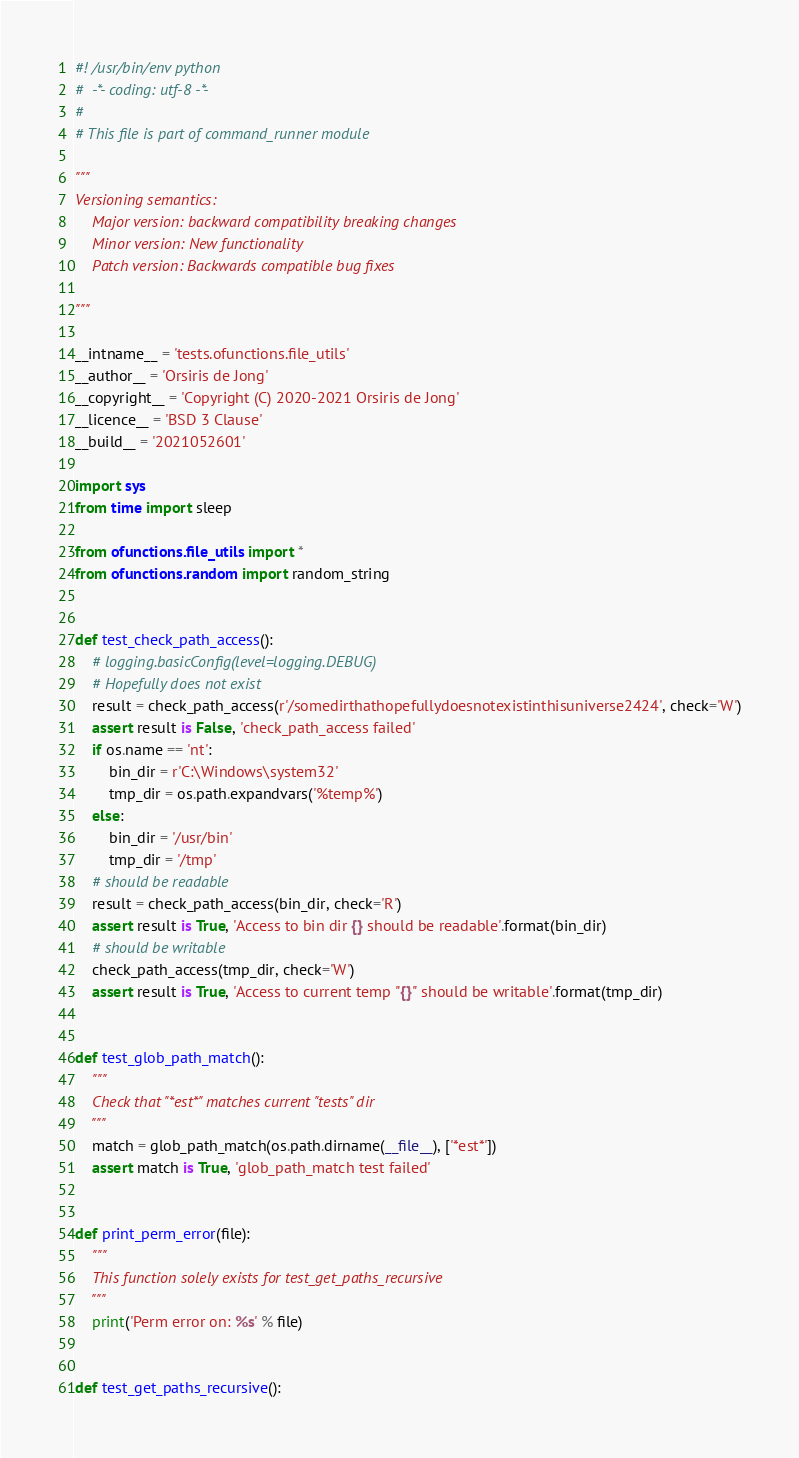<code> <loc_0><loc_0><loc_500><loc_500><_Python_>#! /usr/bin/env python
#  -*- coding: utf-8 -*-
#
# This file is part of command_runner module

"""
Versioning semantics:
    Major version: backward compatibility breaking changes
    Minor version: New functionality
    Patch version: Backwards compatible bug fixes

"""

__intname__ = 'tests.ofunctions.file_utils'
__author__ = 'Orsiris de Jong'
__copyright__ = 'Copyright (C) 2020-2021 Orsiris de Jong'
__licence__ = 'BSD 3 Clause'
__build__ = '2021052601'

import sys
from time import sleep

from ofunctions.file_utils import *
from ofunctions.random import random_string


def test_check_path_access():
    # logging.basicConfig(level=logging.DEBUG)
    # Hopefully does not exist
    result = check_path_access(r'/somedirthathopefullydoesnotexistinthisuniverse2424', check='W')
    assert result is False, 'check_path_access failed'
    if os.name == 'nt':
        bin_dir = r'C:\Windows\system32'
        tmp_dir = os.path.expandvars('%temp%')
    else:
        bin_dir = '/usr/bin'
        tmp_dir = '/tmp'
    # should be readable
    result = check_path_access(bin_dir, check='R')
    assert result is True, 'Access to bin dir {} should be readable'.format(bin_dir)
    # should be writable
    check_path_access(tmp_dir, check='W')
    assert result is True, 'Access to current temp "{}" should be writable'.format(tmp_dir)


def test_glob_path_match():
    """
    Check that "*est*" matches current "tests" dir
    """
    match = glob_path_match(os.path.dirname(__file__), ['*est*'])
    assert match is True, 'glob_path_match test failed'


def print_perm_error(file):
    """
    This function solely exists for test_get_paths_recursive
    """
    print('Perm error on: %s' % file)


def test_get_paths_recursive():</code> 